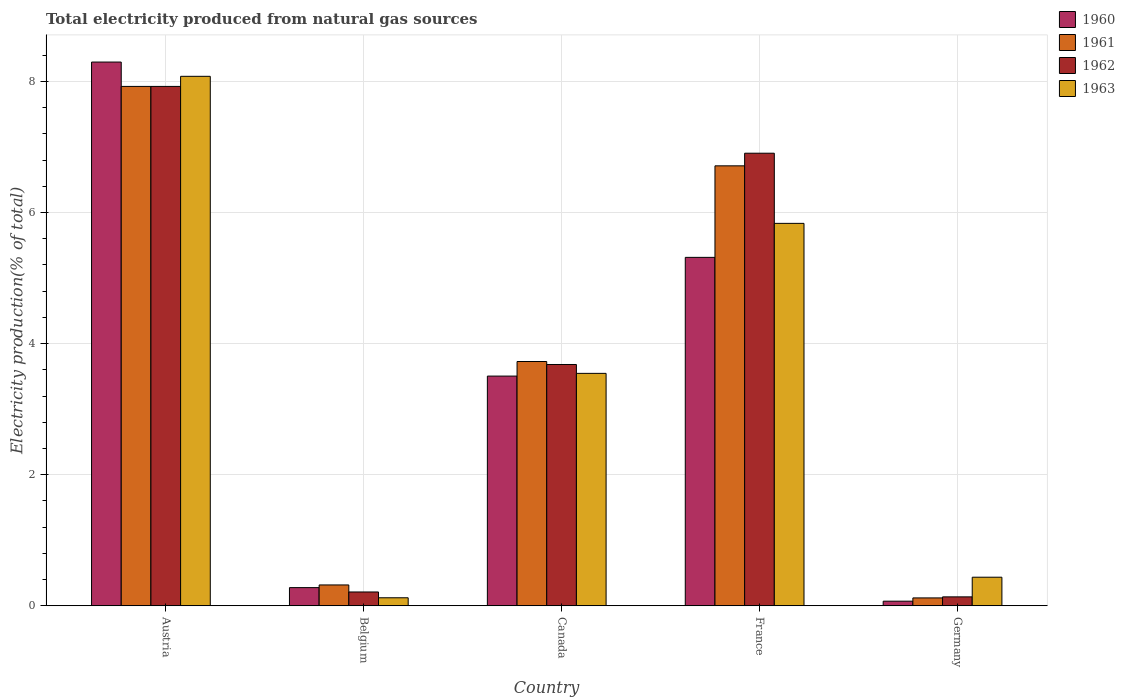How many different coloured bars are there?
Give a very brief answer. 4. How many groups of bars are there?
Give a very brief answer. 5. Are the number of bars per tick equal to the number of legend labels?
Offer a very short reply. Yes. What is the label of the 3rd group of bars from the left?
Make the answer very short. Canada. What is the total electricity produced in 1963 in Austria?
Keep it short and to the point. 8.08. Across all countries, what is the maximum total electricity produced in 1962?
Offer a terse response. 7.92. Across all countries, what is the minimum total electricity produced in 1960?
Your answer should be compact. 0.07. In which country was the total electricity produced in 1962 maximum?
Make the answer very short. Austria. What is the total total electricity produced in 1963 in the graph?
Keep it short and to the point. 18.02. What is the difference between the total electricity produced in 1963 in Austria and that in Belgium?
Provide a succinct answer. 7.96. What is the difference between the total electricity produced in 1961 in France and the total electricity produced in 1962 in Germany?
Make the answer very short. 6.58. What is the average total electricity produced in 1963 per country?
Provide a short and direct response. 3.6. What is the difference between the total electricity produced of/in 1961 and total electricity produced of/in 1960 in Germany?
Keep it short and to the point. 0.05. What is the ratio of the total electricity produced in 1963 in Canada to that in Germany?
Ensure brevity in your answer.  8.13. What is the difference between the highest and the second highest total electricity produced in 1960?
Give a very brief answer. 4.79. What is the difference between the highest and the lowest total electricity produced in 1962?
Provide a short and direct response. 7.79. Is the sum of the total electricity produced in 1960 in France and Germany greater than the maximum total electricity produced in 1963 across all countries?
Make the answer very short. No. Is it the case that in every country, the sum of the total electricity produced in 1960 and total electricity produced in 1961 is greater than the sum of total electricity produced in 1962 and total electricity produced in 1963?
Provide a short and direct response. No. What does the 4th bar from the left in Canada represents?
Your response must be concise. 1963. Is it the case that in every country, the sum of the total electricity produced in 1962 and total electricity produced in 1963 is greater than the total electricity produced in 1961?
Offer a very short reply. Yes. How many bars are there?
Make the answer very short. 20. How many countries are there in the graph?
Your answer should be compact. 5. Are the values on the major ticks of Y-axis written in scientific E-notation?
Give a very brief answer. No. How many legend labels are there?
Your response must be concise. 4. How are the legend labels stacked?
Keep it short and to the point. Vertical. What is the title of the graph?
Offer a terse response. Total electricity produced from natural gas sources. Does "1973" appear as one of the legend labels in the graph?
Your response must be concise. No. What is the label or title of the X-axis?
Your answer should be very brief. Country. What is the Electricity production(% of total) in 1960 in Austria?
Offer a terse response. 8.3. What is the Electricity production(% of total) in 1961 in Austria?
Make the answer very short. 7.92. What is the Electricity production(% of total) in 1962 in Austria?
Offer a terse response. 7.92. What is the Electricity production(% of total) of 1963 in Austria?
Provide a short and direct response. 8.08. What is the Electricity production(% of total) of 1960 in Belgium?
Offer a terse response. 0.28. What is the Electricity production(% of total) in 1961 in Belgium?
Ensure brevity in your answer.  0.32. What is the Electricity production(% of total) of 1962 in Belgium?
Keep it short and to the point. 0.21. What is the Electricity production(% of total) of 1963 in Belgium?
Give a very brief answer. 0.12. What is the Electricity production(% of total) in 1960 in Canada?
Make the answer very short. 3.5. What is the Electricity production(% of total) in 1961 in Canada?
Offer a terse response. 3.73. What is the Electricity production(% of total) of 1962 in Canada?
Your answer should be very brief. 3.68. What is the Electricity production(% of total) of 1963 in Canada?
Your response must be concise. 3.55. What is the Electricity production(% of total) of 1960 in France?
Provide a succinct answer. 5.32. What is the Electricity production(% of total) in 1961 in France?
Offer a terse response. 6.71. What is the Electricity production(% of total) in 1962 in France?
Make the answer very short. 6.91. What is the Electricity production(% of total) of 1963 in France?
Offer a very short reply. 5.83. What is the Electricity production(% of total) of 1960 in Germany?
Your answer should be compact. 0.07. What is the Electricity production(% of total) in 1961 in Germany?
Your answer should be compact. 0.12. What is the Electricity production(% of total) of 1962 in Germany?
Keep it short and to the point. 0.14. What is the Electricity production(% of total) in 1963 in Germany?
Your answer should be compact. 0.44. Across all countries, what is the maximum Electricity production(% of total) of 1960?
Give a very brief answer. 8.3. Across all countries, what is the maximum Electricity production(% of total) of 1961?
Your answer should be very brief. 7.92. Across all countries, what is the maximum Electricity production(% of total) in 1962?
Your answer should be compact. 7.92. Across all countries, what is the maximum Electricity production(% of total) in 1963?
Offer a terse response. 8.08. Across all countries, what is the minimum Electricity production(% of total) of 1960?
Keep it short and to the point. 0.07. Across all countries, what is the minimum Electricity production(% of total) of 1961?
Your answer should be compact. 0.12. Across all countries, what is the minimum Electricity production(% of total) of 1962?
Ensure brevity in your answer.  0.14. Across all countries, what is the minimum Electricity production(% of total) of 1963?
Provide a succinct answer. 0.12. What is the total Electricity production(% of total) in 1960 in the graph?
Your answer should be very brief. 17.46. What is the total Electricity production(% of total) in 1961 in the graph?
Give a very brief answer. 18.8. What is the total Electricity production(% of total) of 1962 in the graph?
Offer a terse response. 18.86. What is the total Electricity production(% of total) in 1963 in the graph?
Offer a very short reply. 18.02. What is the difference between the Electricity production(% of total) of 1960 in Austria and that in Belgium?
Your response must be concise. 8.02. What is the difference between the Electricity production(% of total) of 1961 in Austria and that in Belgium?
Ensure brevity in your answer.  7.61. What is the difference between the Electricity production(% of total) of 1962 in Austria and that in Belgium?
Offer a terse response. 7.71. What is the difference between the Electricity production(% of total) of 1963 in Austria and that in Belgium?
Provide a succinct answer. 7.96. What is the difference between the Electricity production(% of total) of 1960 in Austria and that in Canada?
Make the answer very short. 4.79. What is the difference between the Electricity production(% of total) of 1961 in Austria and that in Canada?
Give a very brief answer. 4.2. What is the difference between the Electricity production(% of total) in 1962 in Austria and that in Canada?
Ensure brevity in your answer.  4.24. What is the difference between the Electricity production(% of total) of 1963 in Austria and that in Canada?
Your response must be concise. 4.53. What is the difference between the Electricity production(% of total) of 1960 in Austria and that in France?
Offer a terse response. 2.98. What is the difference between the Electricity production(% of total) of 1961 in Austria and that in France?
Make the answer very short. 1.21. What is the difference between the Electricity production(% of total) of 1963 in Austria and that in France?
Provide a short and direct response. 2.24. What is the difference between the Electricity production(% of total) of 1960 in Austria and that in Germany?
Your answer should be compact. 8.23. What is the difference between the Electricity production(% of total) in 1961 in Austria and that in Germany?
Ensure brevity in your answer.  7.8. What is the difference between the Electricity production(% of total) in 1962 in Austria and that in Germany?
Provide a succinct answer. 7.79. What is the difference between the Electricity production(% of total) in 1963 in Austria and that in Germany?
Ensure brevity in your answer.  7.64. What is the difference between the Electricity production(% of total) of 1960 in Belgium and that in Canada?
Offer a terse response. -3.23. What is the difference between the Electricity production(% of total) of 1961 in Belgium and that in Canada?
Your response must be concise. -3.41. What is the difference between the Electricity production(% of total) in 1962 in Belgium and that in Canada?
Your response must be concise. -3.47. What is the difference between the Electricity production(% of total) in 1963 in Belgium and that in Canada?
Your response must be concise. -3.42. What is the difference between the Electricity production(% of total) of 1960 in Belgium and that in France?
Make the answer very short. -5.04. What is the difference between the Electricity production(% of total) of 1961 in Belgium and that in France?
Offer a terse response. -6.39. What is the difference between the Electricity production(% of total) of 1962 in Belgium and that in France?
Offer a terse response. -6.69. What is the difference between the Electricity production(% of total) in 1963 in Belgium and that in France?
Keep it short and to the point. -5.71. What is the difference between the Electricity production(% of total) of 1960 in Belgium and that in Germany?
Ensure brevity in your answer.  0.21. What is the difference between the Electricity production(% of total) of 1961 in Belgium and that in Germany?
Provide a succinct answer. 0.2. What is the difference between the Electricity production(% of total) in 1962 in Belgium and that in Germany?
Provide a succinct answer. 0.07. What is the difference between the Electricity production(% of total) of 1963 in Belgium and that in Germany?
Offer a very short reply. -0.31. What is the difference between the Electricity production(% of total) of 1960 in Canada and that in France?
Your response must be concise. -1.81. What is the difference between the Electricity production(% of total) of 1961 in Canada and that in France?
Ensure brevity in your answer.  -2.99. What is the difference between the Electricity production(% of total) in 1962 in Canada and that in France?
Give a very brief answer. -3.22. What is the difference between the Electricity production(% of total) of 1963 in Canada and that in France?
Provide a short and direct response. -2.29. What is the difference between the Electricity production(% of total) of 1960 in Canada and that in Germany?
Provide a succinct answer. 3.43. What is the difference between the Electricity production(% of total) of 1961 in Canada and that in Germany?
Your response must be concise. 3.61. What is the difference between the Electricity production(% of total) in 1962 in Canada and that in Germany?
Provide a short and direct response. 3.55. What is the difference between the Electricity production(% of total) of 1963 in Canada and that in Germany?
Give a very brief answer. 3.11. What is the difference between the Electricity production(% of total) of 1960 in France and that in Germany?
Offer a terse response. 5.25. What is the difference between the Electricity production(% of total) of 1961 in France and that in Germany?
Provide a succinct answer. 6.59. What is the difference between the Electricity production(% of total) of 1962 in France and that in Germany?
Provide a short and direct response. 6.77. What is the difference between the Electricity production(% of total) of 1963 in France and that in Germany?
Your answer should be compact. 5.4. What is the difference between the Electricity production(% of total) of 1960 in Austria and the Electricity production(% of total) of 1961 in Belgium?
Offer a terse response. 7.98. What is the difference between the Electricity production(% of total) of 1960 in Austria and the Electricity production(% of total) of 1962 in Belgium?
Ensure brevity in your answer.  8.08. What is the difference between the Electricity production(% of total) in 1960 in Austria and the Electricity production(% of total) in 1963 in Belgium?
Offer a very short reply. 8.17. What is the difference between the Electricity production(% of total) in 1961 in Austria and the Electricity production(% of total) in 1962 in Belgium?
Provide a short and direct response. 7.71. What is the difference between the Electricity production(% of total) in 1961 in Austria and the Electricity production(% of total) in 1963 in Belgium?
Your answer should be very brief. 7.8. What is the difference between the Electricity production(% of total) in 1962 in Austria and the Electricity production(% of total) in 1963 in Belgium?
Keep it short and to the point. 7.8. What is the difference between the Electricity production(% of total) of 1960 in Austria and the Electricity production(% of total) of 1961 in Canada?
Offer a very short reply. 4.57. What is the difference between the Electricity production(% of total) of 1960 in Austria and the Electricity production(% of total) of 1962 in Canada?
Offer a very short reply. 4.61. What is the difference between the Electricity production(% of total) of 1960 in Austria and the Electricity production(% of total) of 1963 in Canada?
Provide a short and direct response. 4.75. What is the difference between the Electricity production(% of total) in 1961 in Austria and the Electricity production(% of total) in 1962 in Canada?
Your answer should be compact. 4.24. What is the difference between the Electricity production(% of total) in 1961 in Austria and the Electricity production(% of total) in 1963 in Canada?
Offer a very short reply. 4.38. What is the difference between the Electricity production(% of total) in 1962 in Austria and the Electricity production(% of total) in 1963 in Canada?
Keep it short and to the point. 4.38. What is the difference between the Electricity production(% of total) in 1960 in Austria and the Electricity production(% of total) in 1961 in France?
Offer a very short reply. 1.58. What is the difference between the Electricity production(% of total) in 1960 in Austria and the Electricity production(% of total) in 1962 in France?
Offer a terse response. 1.39. What is the difference between the Electricity production(% of total) in 1960 in Austria and the Electricity production(% of total) in 1963 in France?
Ensure brevity in your answer.  2.46. What is the difference between the Electricity production(% of total) of 1961 in Austria and the Electricity production(% of total) of 1962 in France?
Provide a succinct answer. 1.02. What is the difference between the Electricity production(% of total) of 1961 in Austria and the Electricity production(% of total) of 1963 in France?
Your response must be concise. 2.09. What is the difference between the Electricity production(% of total) of 1962 in Austria and the Electricity production(% of total) of 1963 in France?
Offer a terse response. 2.09. What is the difference between the Electricity production(% of total) of 1960 in Austria and the Electricity production(% of total) of 1961 in Germany?
Give a very brief answer. 8.18. What is the difference between the Electricity production(% of total) in 1960 in Austria and the Electricity production(% of total) in 1962 in Germany?
Provide a short and direct response. 8.16. What is the difference between the Electricity production(% of total) in 1960 in Austria and the Electricity production(% of total) in 1963 in Germany?
Your response must be concise. 7.86. What is the difference between the Electricity production(% of total) in 1961 in Austria and the Electricity production(% of total) in 1962 in Germany?
Your answer should be very brief. 7.79. What is the difference between the Electricity production(% of total) in 1961 in Austria and the Electricity production(% of total) in 1963 in Germany?
Offer a very short reply. 7.49. What is the difference between the Electricity production(% of total) in 1962 in Austria and the Electricity production(% of total) in 1963 in Germany?
Your answer should be very brief. 7.49. What is the difference between the Electricity production(% of total) of 1960 in Belgium and the Electricity production(% of total) of 1961 in Canada?
Your answer should be compact. -3.45. What is the difference between the Electricity production(% of total) of 1960 in Belgium and the Electricity production(% of total) of 1962 in Canada?
Your response must be concise. -3.4. What is the difference between the Electricity production(% of total) of 1960 in Belgium and the Electricity production(% of total) of 1963 in Canada?
Give a very brief answer. -3.27. What is the difference between the Electricity production(% of total) of 1961 in Belgium and the Electricity production(% of total) of 1962 in Canada?
Provide a short and direct response. -3.36. What is the difference between the Electricity production(% of total) in 1961 in Belgium and the Electricity production(% of total) in 1963 in Canada?
Your response must be concise. -3.23. What is the difference between the Electricity production(% of total) of 1962 in Belgium and the Electricity production(% of total) of 1963 in Canada?
Ensure brevity in your answer.  -3.34. What is the difference between the Electricity production(% of total) of 1960 in Belgium and the Electricity production(% of total) of 1961 in France?
Your response must be concise. -6.43. What is the difference between the Electricity production(% of total) of 1960 in Belgium and the Electricity production(% of total) of 1962 in France?
Give a very brief answer. -6.63. What is the difference between the Electricity production(% of total) of 1960 in Belgium and the Electricity production(% of total) of 1963 in France?
Your answer should be compact. -5.56. What is the difference between the Electricity production(% of total) of 1961 in Belgium and the Electricity production(% of total) of 1962 in France?
Offer a very short reply. -6.59. What is the difference between the Electricity production(% of total) of 1961 in Belgium and the Electricity production(% of total) of 1963 in France?
Give a very brief answer. -5.52. What is the difference between the Electricity production(% of total) of 1962 in Belgium and the Electricity production(% of total) of 1963 in France?
Your answer should be very brief. -5.62. What is the difference between the Electricity production(% of total) of 1960 in Belgium and the Electricity production(% of total) of 1961 in Germany?
Keep it short and to the point. 0.16. What is the difference between the Electricity production(% of total) of 1960 in Belgium and the Electricity production(% of total) of 1962 in Germany?
Give a very brief answer. 0.14. What is the difference between the Electricity production(% of total) in 1960 in Belgium and the Electricity production(% of total) in 1963 in Germany?
Your response must be concise. -0.16. What is the difference between the Electricity production(% of total) of 1961 in Belgium and the Electricity production(% of total) of 1962 in Germany?
Keep it short and to the point. 0.18. What is the difference between the Electricity production(% of total) in 1961 in Belgium and the Electricity production(% of total) in 1963 in Germany?
Your answer should be compact. -0.12. What is the difference between the Electricity production(% of total) of 1962 in Belgium and the Electricity production(% of total) of 1963 in Germany?
Offer a very short reply. -0.23. What is the difference between the Electricity production(% of total) of 1960 in Canada and the Electricity production(% of total) of 1961 in France?
Give a very brief answer. -3.21. What is the difference between the Electricity production(% of total) in 1960 in Canada and the Electricity production(% of total) in 1962 in France?
Provide a short and direct response. -3.4. What is the difference between the Electricity production(% of total) of 1960 in Canada and the Electricity production(% of total) of 1963 in France?
Make the answer very short. -2.33. What is the difference between the Electricity production(% of total) of 1961 in Canada and the Electricity production(% of total) of 1962 in France?
Give a very brief answer. -3.18. What is the difference between the Electricity production(% of total) of 1961 in Canada and the Electricity production(% of total) of 1963 in France?
Your answer should be compact. -2.11. What is the difference between the Electricity production(% of total) in 1962 in Canada and the Electricity production(% of total) in 1963 in France?
Offer a very short reply. -2.15. What is the difference between the Electricity production(% of total) of 1960 in Canada and the Electricity production(% of total) of 1961 in Germany?
Offer a terse response. 3.38. What is the difference between the Electricity production(% of total) in 1960 in Canada and the Electricity production(% of total) in 1962 in Germany?
Offer a very short reply. 3.37. What is the difference between the Electricity production(% of total) of 1960 in Canada and the Electricity production(% of total) of 1963 in Germany?
Your answer should be compact. 3.07. What is the difference between the Electricity production(% of total) in 1961 in Canada and the Electricity production(% of total) in 1962 in Germany?
Offer a very short reply. 3.59. What is the difference between the Electricity production(% of total) in 1961 in Canada and the Electricity production(% of total) in 1963 in Germany?
Offer a terse response. 3.29. What is the difference between the Electricity production(% of total) of 1962 in Canada and the Electricity production(% of total) of 1963 in Germany?
Offer a very short reply. 3.25. What is the difference between the Electricity production(% of total) in 1960 in France and the Electricity production(% of total) in 1961 in Germany?
Make the answer very short. 5.2. What is the difference between the Electricity production(% of total) of 1960 in France and the Electricity production(% of total) of 1962 in Germany?
Provide a succinct answer. 5.18. What is the difference between the Electricity production(% of total) in 1960 in France and the Electricity production(% of total) in 1963 in Germany?
Give a very brief answer. 4.88. What is the difference between the Electricity production(% of total) of 1961 in France and the Electricity production(% of total) of 1962 in Germany?
Provide a succinct answer. 6.58. What is the difference between the Electricity production(% of total) in 1961 in France and the Electricity production(% of total) in 1963 in Germany?
Keep it short and to the point. 6.28. What is the difference between the Electricity production(% of total) in 1962 in France and the Electricity production(% of total) in 1963 in Germany?
Give a very brief answer. 6.47. What is the average Electricity production(% of total) of 1960 per country?
Your response must be concise. 3.49. What is the average Electricity production(% of total) of 1961 per country?
Ensure brevity in your answer.  3.76. What is the average Electricity production(% of total) in 1962 per country?
Ensure brevity in your answer.  3.77. What is the average Electricity production(% of total) in 1963 per country?
Offer a terse response. 3.6. What is the difference between the Electricity production(% of total) of 1960 and Electricity production(% of total) of 1961 in Austria?
Your answer should be very brief. 0.37. What is the difference between the Electricity production(% of total) of 1960 and Electricity production(% of total) of 1962 in Austria?
Your answer should be very brief. 0.37. What is the difference between the Electricity production(% of total) of 1960 and Electricity production(% of total) of 1963 in Austria?
Give a very brief answer. 0.22. What is the difference between the Electricity production(% of total) in 1961 and Electricity production(% of total) in 1963 in Austria?
Provide a succinct answer. -0.15. What is the difference between the Electricity production(% of total) of 1962 and Electricity production(% of total) of 1963 in Austria?
Give a very brief answer. -0.15. What is the difference between the Electricity production(% of total) in 1960 and Electricity production(% of total) in 1961 in Belgium?
Your response must be concise. -0.04. What is the difference between the Electricity production(% of total) of 1960 and Electricity production(% of total) of 1962 in Belgium?
Your response must be concise. 0.07. What is the difference between the Electricity production(% of total) in 1960 and Electricity production(% of total) in 1963 in Belgium?
Your answer should be compact. 0.15. What is the difference between the Electricity production(% of total) of 1961 and Electricity production(% of total) of 1962 in Belgium?
Provide a succinct answer. 0.11. What is the difference between the Electricity production(% of total) of 1961 and Electricity production(% of total) of 1963 in Belgium?
Offer a terse response. 0.2. What is the difference between the Electricity production(% of total) of 1962 and Electricity production(% of total) of 1963 in Belgium?
Provide a succinct answer. 0.09. What is the difference between the Electricity production(% of total) in 1960 and Electricity production(% of total) in 1961 in Canada?
Make the answer very short. -0.22. What is the difference between the Electricity production(% of total) in 1960 and Electricity production(% of total) in 1962 in Canada?
Your response must be concise. -0.18. What is the difference between the Electricity production(% of total) in 1960 and Electricity production(% of total) in 1963 in Canada?
Offer a terse response. -0.04. What is the difference between the Electricity production(% of total) in 1961 and Electricity production(% of total) in 1962 in Canada?
Make the answer very short. 0.05. What is the difference between the Electricity production(% of total) of 1961 and Electricity production(% of total) of 1963 in Canada?
Make the answer very short. 0.18. What is the difference between the Electricity production(% of total) in 1962 and Electricity production(% of total) in 1963 in Canada?
Your response must be concise. 0.14. What is the difference between the Electricity production(% of total) of 1960 and Electricity production(% of total) of 1961 in France?
Your response must be concise. -1.4. What is the difference between the Electricity production(% of total) of 1960 and Electricity production(% of total) of 1962 in France?
Give a very brief answer. -1.59. What is the difference between the Electricity production(% of total) in 1960 and Electricity production(% of total) in 1963 in France?
Your answer should be compact. -0.52. What is the difference between the Electricity production(% of total) in 1961 and Electricity production(% of total) in 1962 in France?
Offer a very short reply. -0.19. What is the difference between the Electricity production(% of total) in 1961 and Electricity production(% of total) in 1963 in France?
Provide a short and direct response. 0.88. What is the difference between the Electricity production(% of total) of 1962 and Electricity production(% of total) of 1963 in France?
Your answer should be very brief. 1.07. What is the difference between the Electricity production(% of total) of 1960 and Electricity production(% of total) of 1961 in Germany?
Provide a short and direct response. -0.05. What is the difference between the Electricity production(% of total) in 1960 and Electricity production(% of total) in 1962 in Germany?
Offer a very short reply. -0.07. What is the difference between the Electricity production(% of total) of 1960 and Electricity production(% of total) of 1963 in Germany?
Make the answer very short. -0.37. What is the difference between the Electricity production(% of total) of 1961 and Electricity production(% of total) of 1962 in Germany?
Provide a succinct answer. -0.02. What is the difference between the Electricity production(% of total) in 1961 and Electricity production(% of total) in 1963 in Germany?
Keep it short and to the point. -0.32. What is the difference between the Electricity production(% of total) of 1962 and Electricity production(% of total) of 1963 in Germany?
Ensure brevity in your answer.  -0.3. What is the ratio of the Electricity production(% of total) in 1960 in Austria to that in Belgium?
Offer a very short reply. 29.93. What is the ratio of the Electricity production(% of total) of 1961 in Austria to that in Belgium?
Provide a succinct answer. 24.9. What is the ratio of the Electricity production(% of total) of 1962 in Austria to that in Belgium?
Offer a very short reply. 37.57. What is the ratio of the Electricity production(% of total) in 1963 in Austria to that in Belgium?
Your answer should be very brief. 66.07. What is the ratio of the Electricity production(% of total) in 1960 in Austria to that in Canada?
Offer a terse response. 2.37. What is the ratio of the Electricity production(% of total) of 1961 in Austria to that in Canada?
Your answer should be very brief. 2.13. What is the ratio of the Electricity production(% of total) of 1962 in Austria to that in Canada?
Give a very brief answer. 2.15. What is the ratio of the Electricity production(% of total) of 1963 in Austria to that in Canada?
Give a very brief answer. 2.28. What is the ratio of the Electricity production(% of total) in 1960 in Austria to that in France?
Ensure brevity in your answer.  1.56. What is the ratio of the Electricity production(% of total) of 1961 in Austria to that in France?
Keep it short and to the point. 1.18. What is the ratio of the Electricity production(% of total) of 1962 in Austria to that in France?
Offer a very short reply. 1.15. What is the ratio of the Electricity production(% of total) in 1963 in Austria to that in France?
Your answer should be compact. 1.38. What is the ratio of the Electricity production(% of total) in 1960 in Austria to that in Germany?
Provide a short and direct response. 118.01. What is the ratio of the Electricity production(% of total) in 1961 in Austria to that in Germany?
Provide a short and direct response. 65.86. What is the ratio of the Electricity production(% of total) of 1962 in Austria to that in Germany?
Provide a succinct answer. 58.17. What is the ratio of the Electricity production(% of total) in 1963 in Austria to that in Germany?
Offer a terse response. 18.52. What is the ratio of the Electricity production(% of total) of 1960 in Belgium to that in Canada?
Your answer should be very brief. 0.08. What is the ratio of the Electricity production(% of total) in 1961 in Belgium to that in Canada?
Offer a very short reply. 0.09. What is the ratio of the Electricity production(% of total) of 1962 in Belgium to that in Canada?
Make the answer very short. 0.06. What is the ratio of the Electricity production(% of total) of 1963 in Belgium to that in Canada?
Provide a succinct answer. 0.03. What is the ratio of the Electricity production(% of total) of 1960 in Belgium to that in France?
Give a very brief answer. 0.05. What is the ratio of the Electricity production(% of total) of 1961 in Belgium to that in France?
Provide a short and direct response. 0.05. What is the ratio of the Electricity production(% of total) of 1962 in Belgium to that in France?
Give a very brief answer. 0.03. What is the ratio of the Electricity production(% of total) of 1963 in Belgium to that in France?
Your response must be concise. 0.02. What is the ratio of the Electricity production(% of total) in 1960 in Belgium to that in Germany?
Keep it short and to the point. 3.94. What is the ratio of the Electricity production(% of total) in 1961 in Belgium to that in Germany?
Your answer should be very brief. 2.64. What is the ratio of the Electricity production(% of total) in 1962 in Belgium to that in Germany?
Make the answer very short. 1.55. What is the ratio of the Electricity production(% of total) in 1963 in Belgium to that in Germany?
Provide a succinct answer. 0.28. What is the ratio of the Electricity production(% of total) of 1960 in Canada to that in France?
Your answer should be very brief. 0.66. What is the ratio of the Electricity production(% of total) in 1961 in Canada to that in France?
Ensure brevity in your answer.  0.56. What is the ratio of the Electricity production(% of total) of 1962 in Canada to that in France?
Give a very brief answer. 0.53. What is the ratio of the Electricity production(% of total) in 1963 in Canada to that in France?
Provide a short and direct response. 0.61. What is the ratio of the Electricity production(% of total) in 1960 in Canada to that in Germany?
Provide a succinct answer. 49.85. What is the ratio of the Electricity production(% of total) of 1961 in Canada to that in Germany?
Your answer should be very brief. 30.98. What is the ratio of the Electricity production(% of total) of 1962 in Canada to that in Germany?
Give a very brief answer. 27.02. What is the ratio of the Electricity production(% of total) of 1963 in Canada to that in Germany?
Your answer should be compact. 8.13. What is the ratio of the Electricity production(% of total) in 1960 in France to that in Germany?
Offer a terse response. 75.62. What is the ratio of the Electricity production(% of total) of 1961 in France to that in Germany?
Provide a short and direct response. 55.79. What is the ratio of the Electricity production(% of total) in 1962 in France to that in Germany?
Provide a short and direct response. 50.69. What is the ratio of the Electricity production(% of total) of 1963 in France to that in Germany?
Your response must be concise. 13.38. What is the difference between the highest and the second highest Electricity production(% of total) of 1960?
Offer a very short reply. 2.98. What is the difference between the highest and the second highest Electricity production(% of total) of 1961?
Offer a very short reply. 1.21. What is the difference between the highest and the second highest Electricity production(% of total) of 1963?
Ensure brevity in your answer.  2.24. What is the difference between the highest and the lowest Electricity production(% of total) in 1960?
Offer a terse response. 8.23. What is the difference between the highest and the lowest Electricity production(% of total) in 1961?
Keep it short and to the point. 7.8. What is the difference between the highest and the lowest Electricity production(% of total) in 1962?
Give a very brief answer. 7.79. What is the difference between the highest and the lowest Electricity production(% of total) of 1963?
Your response must be concise. 7.96. 